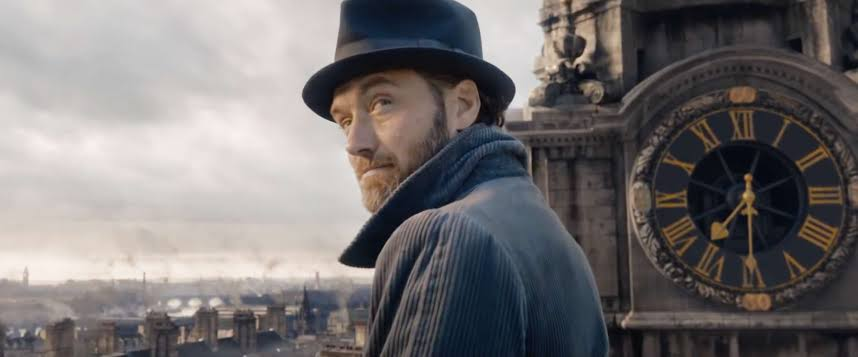What time period does the attire of the individual suggest? The clothing worn by the person in the image, specifically the tailored blue coat and top hat, has a vintage appeal that may suggest a setting in the late 19th to early 20th century. Such attire reflects fashion from a time when formal, structured clothing was commonplace in daily wear for certain social classes or occupations. 